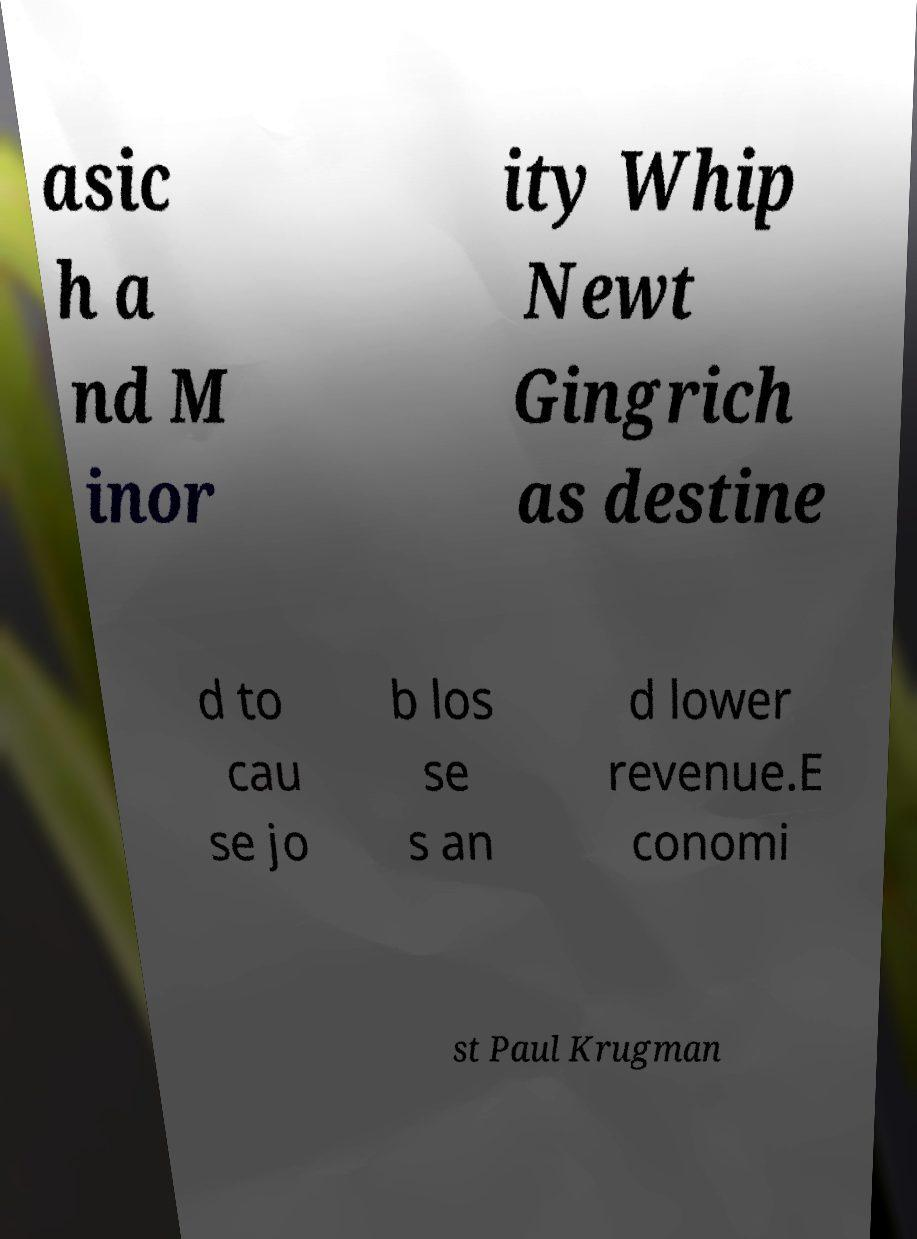What messages or text are displayed in this image? I need them in a readable, typed format. asic h a nd M inor ity Whip Newt Gingrich as destine d to cau se jo b los se s an d lower revenue.E conomi st Paul Krugman 